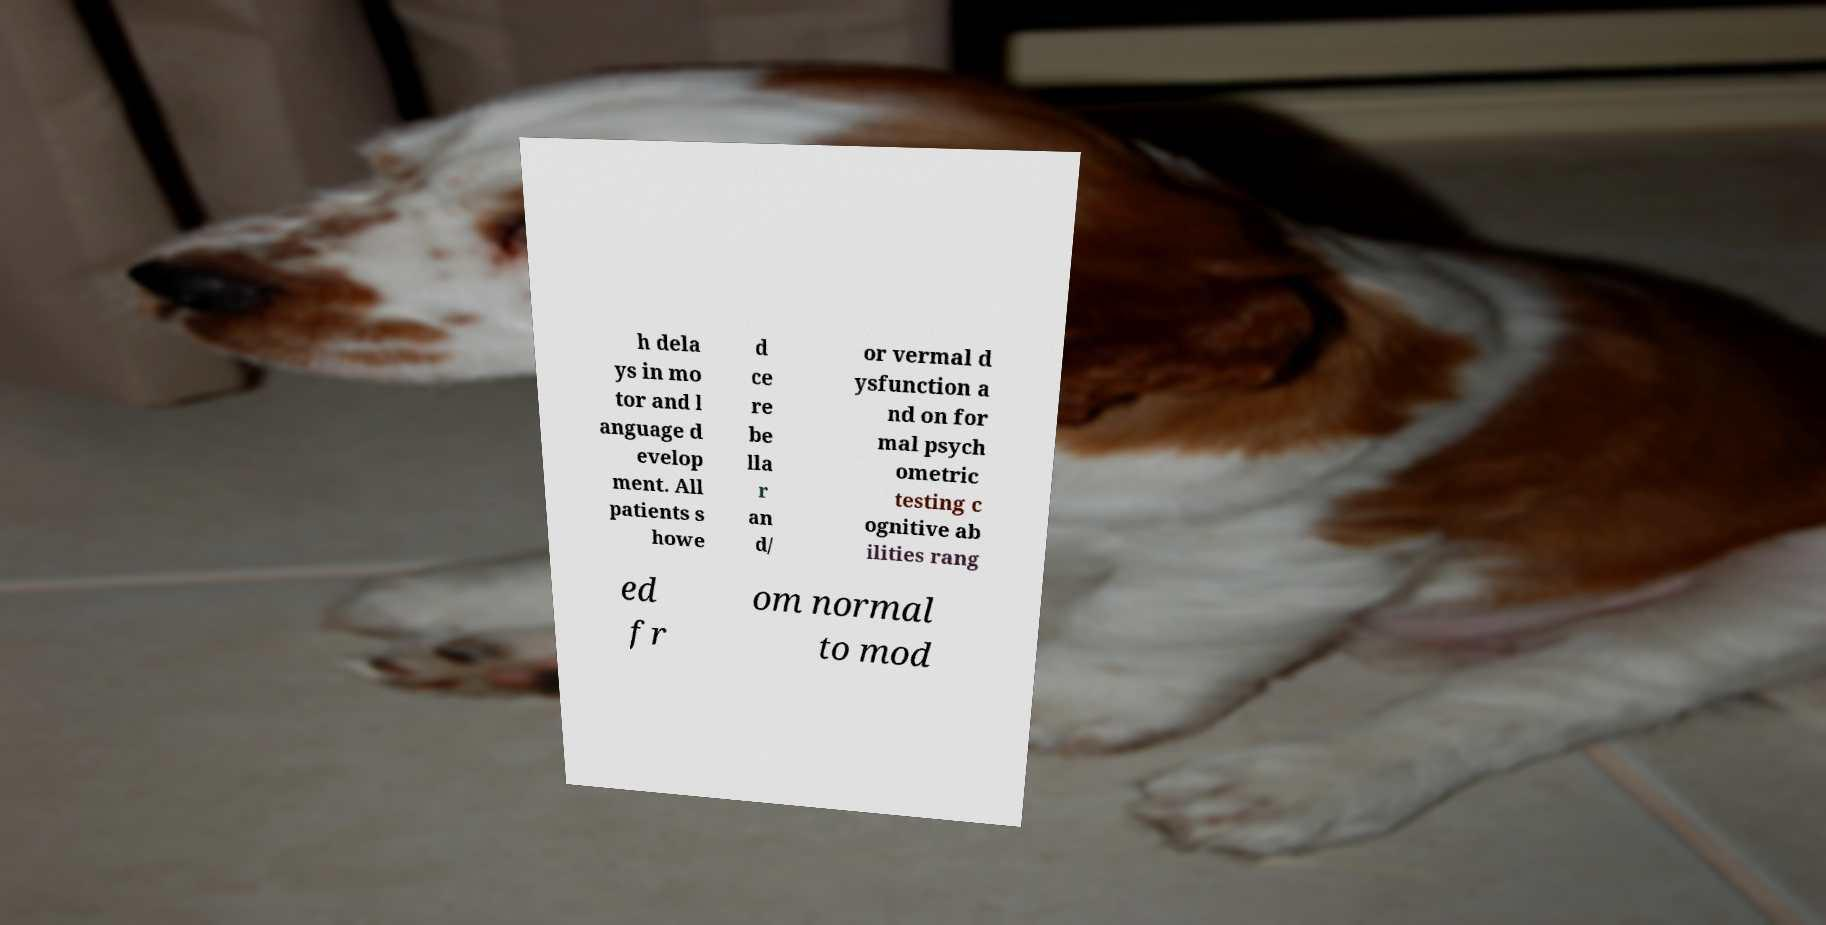Please identify and transcribe the text found in this image. h dela ys in mo tor and l anguage d evelop ment. All patients s howe d ce re be lla r an d/ or vermal d ysfunction a nd on for mal psych ometric testing c ognitive ab ilities rang ed fr om normal to mod 